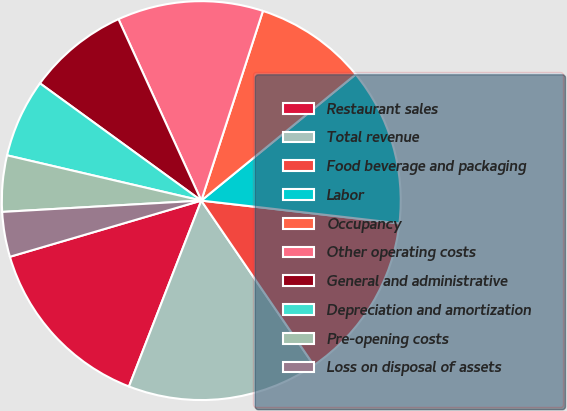<chart> <loc_0><loc_0><loc_500><loc_500><pie_chart><fcel>Restaurant sales<fcel>Total revenue<fcel>Food beverage and packaging<fcel>Labor<fcel>Occupancy<fcel>Other operating costs<fcel>General and administrative<fcel>Depreciation and amortization<fcel>Pre-opening costs<fcel>Loss on disposal of assets<nl><fcel>14.55%<fcel>15.45%<fcel>13.64%<fcel>12.73%<fcel>9.09%<fcel>11.82%<fcel>8.18%<fcel>6.36%<fcel>4.55%<fcel>3.64%<nl></chart> 